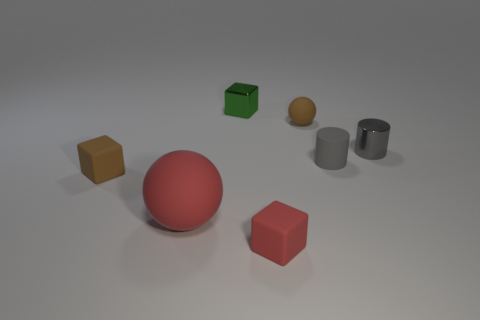Add 3 large matte balls. How many objects exist? 10 Subtract all blocks. How many objects are left? 4 Add 4 matte objects. How many matte objects exist? 9 Subtract 0 brown cylinders. How many objects are left? 7 Subtract all small rubber spheres. Subtract all tiny red rubber cubes. How many objects are left? 5 Add 3 gray metal objects. How many gray metal objects are left? 4 